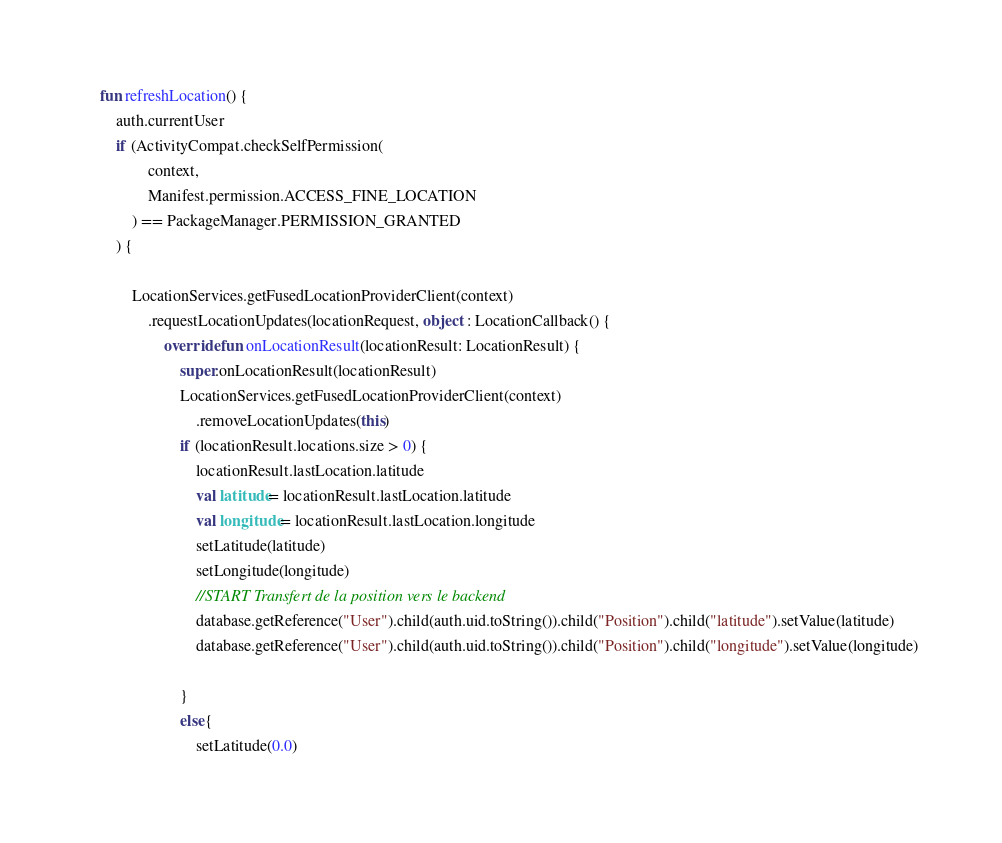<code> <loc_0><loc_0><loc_500><loc_500><_Kotlin_>    fun refreshLocation() {
        auth.currentUser
        if (ActivityCompat.checkSelfPermission(
                context,
                Manifest.permission.ACCESS_FINE_LOCATION
            ) == PackageManager.PERMISSION_GRANTED
        ) {

            LocationServices.getFusedLocationProviderClient(context)
                .requestLocationUpdates(locationRequest, object : LocationCallback() {
                    override fun onLocationResult(locationResult: LocationResult) {
                        super.onLocationResult(locationResult)
                        LocationServices.getFusedLocationProviderClient(context)
                            .removeLocationUpdates(this)
                        if (locationResult.locations.size > 0) {
                            locationResult.lastLocation.latitude
                            val latitude= locationResult.lastLocation.latitude
                            val longitude= locationResult.lastLocation.longitude
                            setLatitude(latitude)
                            setLongitude(longitude)
                            //START Transfert de la position vers le backend
                            database.getReference("User").child(auth.uid.toString()).child("Position").child("latitude").setValue(latitude)
                            database.getReference("User").child(auth.uid.toString()).child("Position").child("longitude").setValue(longitude)

                        }
                        else{
                            setLatitude(0.0)</code> 